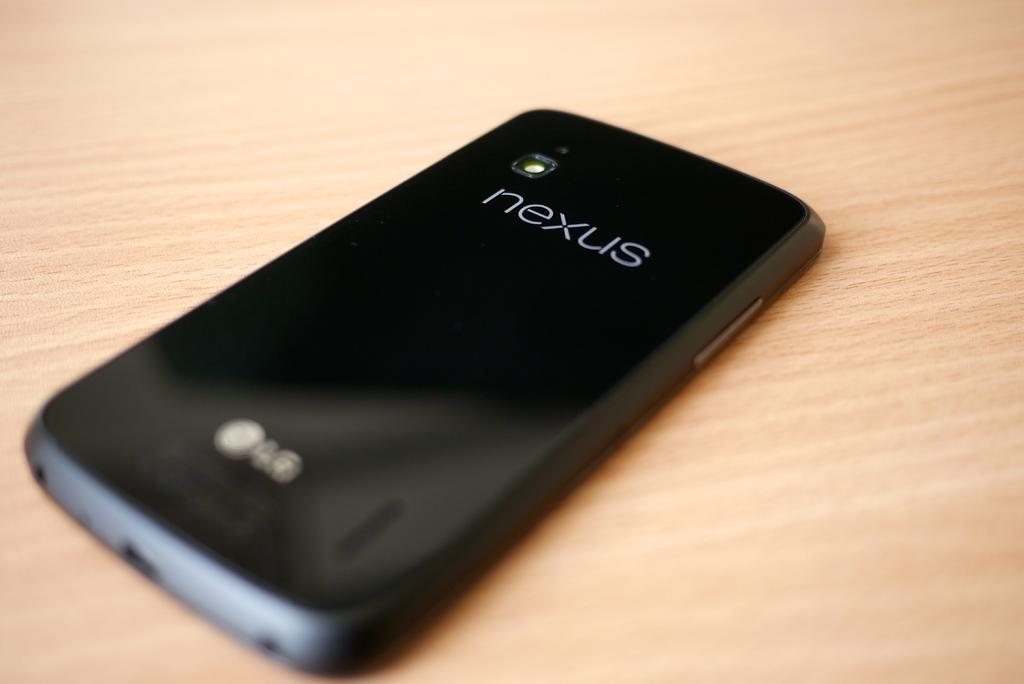<image>
Offer a succinct explanation of the picture presented. Black Nexus phone face down on a brown table. 